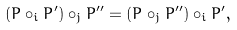Convert formula to latex. <formula><loc_0><loc_0><loc_500><loc_500>( P \circ _ { i } P ^ { \prime } ) \circ _ { j } P ^ { \prime \prime } = ( P \circ _ { j } P ^ { \prime \prime } ) \circ _ { i } P ^ { \prime } ,</formula> 